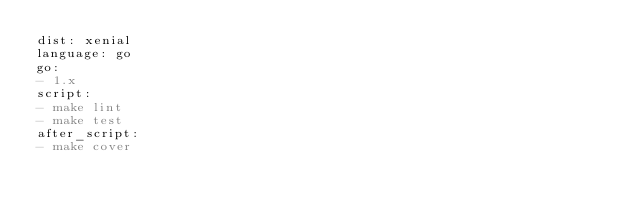Convert code to text. <code><loc_0><loc_0><loc_500><loc_500><_YAML_>dist: xenial
language: go
go:
- 1.x
script:
- make lint
- make test
after_script:
- make cover
</code> 